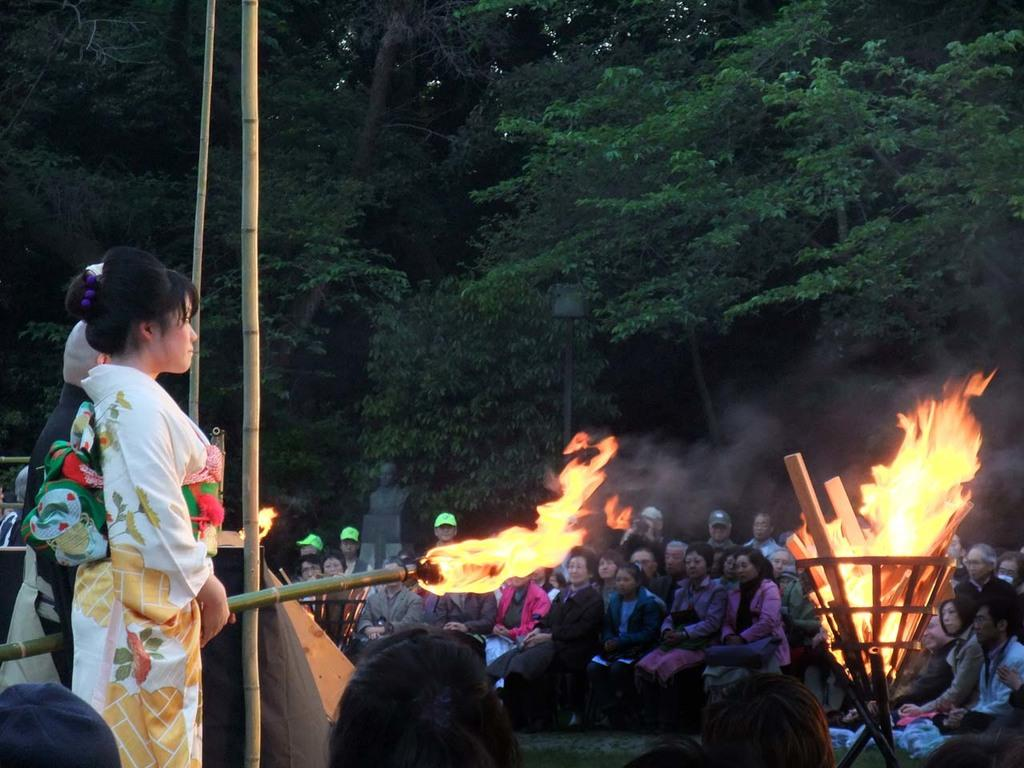What is the primary subject of the image? There is a woman standing in the image. What are the other people in the image doing? There are people sitting in the image. What can be seen in the background of the image? There are trees present in the image. What is the source of light or heat in the image? There is fire visible in the image. What type of girl is playing with the tank in the image? There is no girl or tank present in the image. 